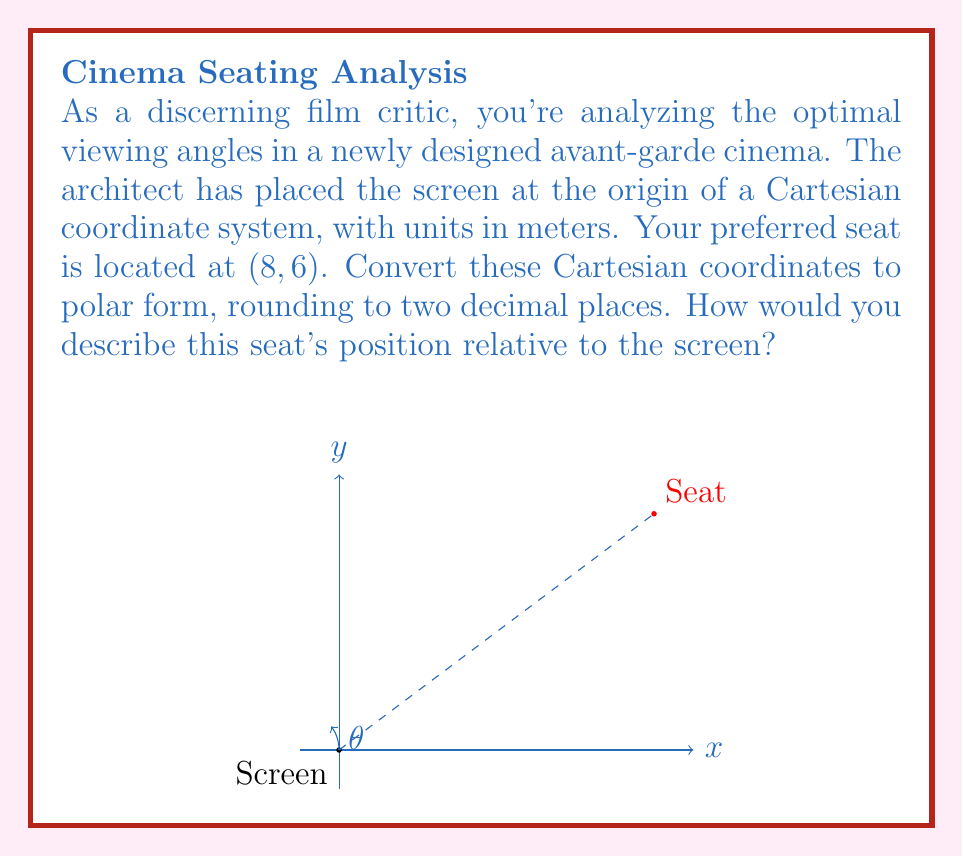Provide a solution to this math problem. To convert Cartesian coordinates (x, y) to polar coordinates (r, θ), we use the following formulas:

1. $r = \sqrt{x^2 + y^2}$
2. $\theta = \tan^{-1}(\frac{y}{x})$

For the given seat position (8, 6):

1. Calculate r:
   $$r = \sqrt{8^2 + 6^2} = \sqrt{64 + 36} = \sqrt{100} = 10$$

2. Calculate θ:
   $$\theta = \tan^{-1}(\frac{6}{8}) = \tan^{-1}(0.75) \approx 0.6435 \text{ radians}$$

3. Convert radians to degrees:
   $$0.6435 \text{ radians} \times \frac{180°}{\pi} \approx 36.87°$$

4. Round both values to two decimal places:
   r ≈ 10.00 meters
   θ ≈ 36.87°

Therefore, in polar coordinates, the seat's position is approximately (10.00, 36.87°).

Interpretation: The seat is located 10 meters from the screen at an angle of about 37° above the horizontal, providing a slightly elevated view of the screen.
Answer: (10.00, 36.87°) 